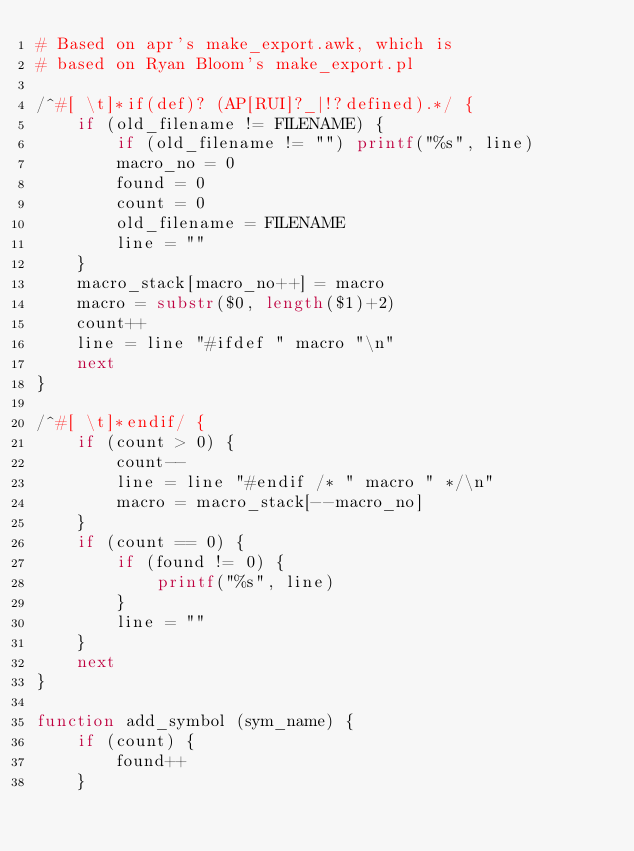<code> <loc_0><loc_0><loc_500><loc_500><_Awk_># Based on apr's make_export.awk, which is
# based on Ryan Bloom's make_export.pl

/^#[ \t]*if(def)? (AP[RUI]?_|!?defined).*/ {
	if (old_filename != FILENAME) {
		if (old_filename != "") printf("%s", line)
		macro_no = 0
		found = 0
		count = 0
		old_filename = FILENAME
		line = ""
	}
	macro_stack[macro_no++] = macro
	macro = substr($0, length($1)+2)
	count++
	line = line "#ifdef " macro "\n"
	next
}

/^#[ \t]*endif/ {
	if (count > 0) {
		count--
		line = line "#endif /* " macro " */\n"
		macro = macro_stack[--macro_no]
	}
	if (count == 0) {
		if (found != 0) {
			printf("%s", line)
		}
		line = ""
	}
	next
}

function add_symbol (sym_name) {
	if (count) {
		found++
	}</code> 